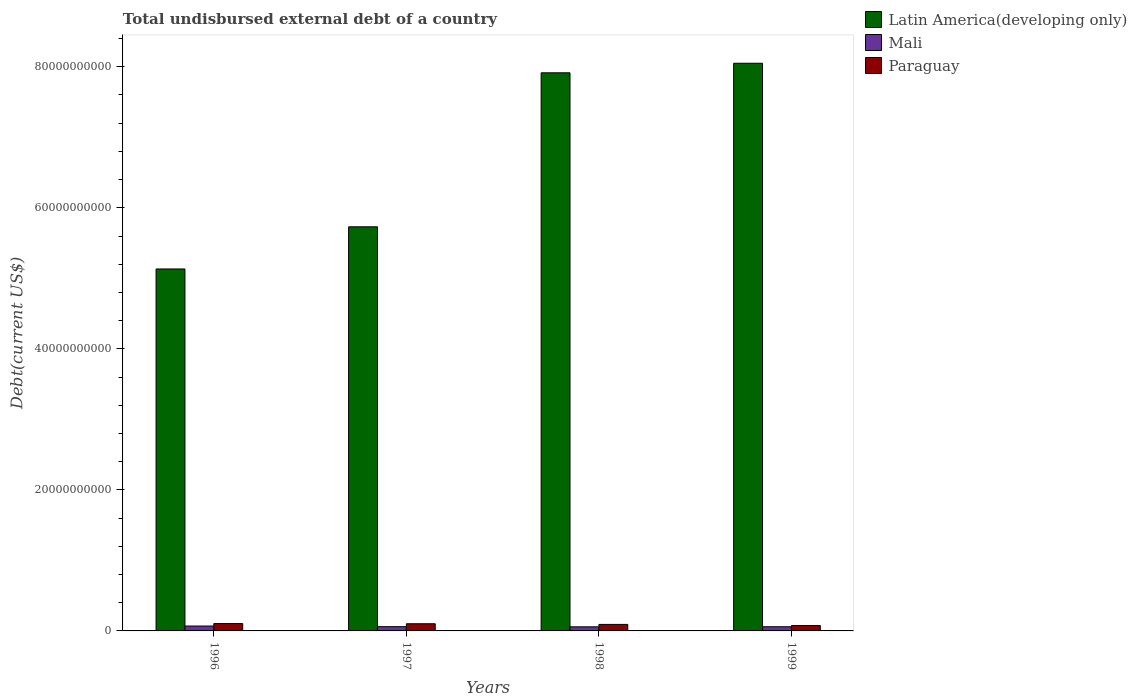How many different coloured bars are there?
Your answer should be compact. 3. How many groups of bars are there?
Keep it short and to the point. 4. Are the number of bars on each tick of the X-axis equal?
Keep it short and to the point. Yes. How many bars are there on the 3rd tick from the left?
Offer a very short reply. 3. What is the label of the 2nd group of bars from the left?
Offer a very short reply. 1997. In how many cases, is the number of bars for a given year not equal to the number of legend labels?
Provide a succinct answer. 0. What is the total undisbursed external debt in Mali in 1996?
Your response must be concise. 6.94e+08. Across all years, what is the maximum total undisbursed external debt in Latin America(developing only)?
Your answer should be very brief. 8.05e+1. Across all years, what is the minimum total undisbursed external debt in Mali?
Provide a short and direct response. 5.82e+08. What is the total total undisbursed external debt in Paraguay in the graph?
Provide a succinct answer. 3.75e+09. What is the difference between the total undisbursed external debt in Mali in 1996 and that in 1998?
Ensure brevity in your answer.  1.12e+08. What is the difference between the total undisbursed external debt in Latin America(developing only) in 1997 and the total undisbursed external debt in Mali in 1999?
Keep it short and to the point. 5.67e+1. What is the average total undisbursed external debt in Latin America(developing only) per year?
Keep it short and to the point. 6.71e+1. In the year 1999, what is the difference between the total undisbursed external debt in Latin America(developing only) and total undisbursed external debt in Paraguay?
Provide a short and direct response. 7.97e+1. What is the ratio of the total undisbursed external debt in Latin America(developing only) in 1997 to that in 1999?
Your answer should be compact. 0.71. Is the total undisbursed external debt in Paraguay in 1996 less than that in 1997?
Make the answer very short. No. What is the difference between the highest and the second highest total undisbursed external debt in Paraguay?
Your answer should be very brief. 2.45e+07. What is the difference between the highest and the lowest total undisbursed external debt in Paraguay?
Give a very brief answer. 2.79e+08. What does the 2nd bar from the left in 1996 represents?
Offer a very short reply. Mali. What does the 3rd bar from the right in 1999 represents?
Your answer should be compact. Latin America(developing only). Is it the case that in every year, the sum of the total undisbursed external debt in Paraguay and total undisbursed external debt in Mali is greater than the total undisbursed external debt in Latin America(developing only)?
Provide a succinct answer. No. How many bars are there?
Make the answer very short. 12. Does the graph contain grids?
Keep it short and to the point. No. Where does the legend appear in the graph?
Offer a terse response. Top right. How many legend labels are there?
Provide a succinct answer. 3. What is the title of the graph?
Make the answer very short. Total undisbursed external debt of a country. Does "Mexico" appear as one of the legend labels in the graph?
Provide a short and direct response. No. What is the label or title of the Y-axis?
Ensure brevity in your answer.  Debt(current US$). What is the Debt(current US$) of Latin America(developing only) in 1996?
Your response must be concise. 5.13e+1. What is the Debt(current US$) in Mali in 1996?
Offer a very short reply. 6.94e+08. What is the Debt(current US$) in Paraguay in 1996?
Provide a succinct answer. 1.04e+09. What is the Debt(current US$) in Latin America(developing only) in 1997?
Offer a very short reply. 5.73e+1. What is the Debt(current US$) in Mali in 1997?
Give a very brief answer. 6.03e+08. What is the Debt(current US$) in Paraguay in 1997?
Offer a very short reply. 1.02e+09. What is the Debt(current US$) in Latin America(developing only) in 1998?
Keep it short and to the point. 7.91e+1. What is the Debt(current US$) of Mali in 1998?
Make the answer very short. 5.82e+08. What is the Debt(current US$) of Paraguay in 1998?
Offer a very short reply. 9.22e+08. What is the Debt(current US$) of Latin America(developing only) in 1999?
Ensure brevity in your answer.  8.05e+1. What is the Debt(current US$) in Mali in 1999?
Keep it short and to the point. 5.93e+08. What is the Debt(current US$) in Paraguay in 1999?
Ensure brevity in your answer.  7.64e+08. Across all years, what is the maximum Debt(current US$) in Latin America(developing only)?
Provide a short and direct response. 8.05e+1. Across all years, what is the maximum Debt(current US$) of Mali?
Give a very brief answer. 6.94e+08. Across all years, what is the maximum Debt(current US$) of Paraguay?
Make the answer very short. 1.04e+09. Across all years, what is the minimum Debt(current US$) of Latin America(developing only)?
Give a very brief answer. 5.13e+1. Across all years, what is the minimum Debt(current US$) of Mali?
Offer a very short reply. 5.82e+08. Across all years, what is the minimum Debt(current US$) of Paraguay?
Offer a very short reply. 7.64e+08. What is the total Debt(current US$) of Latin America(developing only) in the graph?
Provide a short and direct response. 2.68e+11. What is the total Debt(current US$) in Mali in the graph?
Ensure brevity in your answer.  2.47e+09. What is the total Debt(current US$) in Paraguay in the graph?
Make the answer very short. 3.75e+09. What is the difference between the Debt(current US$) in Latin America(developing only) in 1996 and that in 1997?
Your answer should be compact. -5.98e+09. What is the difference between the Debt(current US$) of Mali in 1996 and that in 1997?
Make the answer very short. 9.09e+07. What is the difference between the Debt(current US$) of Paraguay in 1996 and that in 1997?
Offer a very short reply. 2.45e+07. What is the difference between the Debt(current US$) in Latin America(developing only) in 1996 and that in 1998?
Provide a succinct answer. -2.78e+1. What is the difference between the Debt(current US$) of Mali in 1996 and that in 1998?
Make the answer very short. 1.12e+08. What is the difference between the Debt(current US$) in Paraguay in 1996 and that in 1998?
Make the answer very short. 1.21e+08. What is the difference between the Debt(current US$) of Latin America(developing only) in 1996 and that in 1999?
Ensure brevity in your answer.  -2.92e+1. What is the difference between the Debt(current US$) of Mali in 1996 and that in 1999?
Ensure brevity in your answer.  1.01e+08. What is the difference between the Debt(current US$) in Paraguay in 1996 and that in 1999?
Offer a terse response. 2.79e+08. What is the difference between the Debt(current US$) in Latin America(developing only) in 1997 and that in 1998?
Keep it short and to the point. -2.18e+1. What is the difference between the Debt(current US$) of Mali in 1997 and that in 1998?
Give a very brief answer. 2.14e+07. What is the difference between the Debt(current US$) in Paraguay in 1997 and that in 1998?
Give a very brief answer. 9.61e+07. What is the difference between the Debt(current US$) in Latin America(developing only) in 1997 and that in 1999?
Provide a succinct answer. -2.32e+1. What is the difference between the Debt(current US$) in Mali in 1997 and that in 1999?
Offer a terse response. 1.00e+07. What is the difference between the Debt(current US$) in Paraguay in 1997 and that in 1999?
Your response must be concise. 2.54e+08. What is the difference between the Debt(current US$) in Latin America(developing only) in 1998 and that in 1999?
Keep it short and to the point. -1.35e+09. What is the difference between the Debt(current US$) of Mali in 1998 and that in 1999?
Give a very brief answer. -1.13e+07. What is the difference between the Debt(current US$) of Paraguay in 1998 and that in 1999?
Your response must be concise. 1.58e+08. What is the difference between the Debt(current US$) in Latin America(developing only) in 1996 and the Debt(current US$) in Mali in 1997?
Provide a succinct answer. 5.07e+1. What is the difference between the Debt(current US$) in Latin America(developing only) in 1996 and the Debt(current US$) in Paraguay in 1997?
Your answer should be compact. 5.03e+1. What is the difference between the Debt(current US$) in Mali in 1996 and the Debt(current US$) in Paraguay in 1997?
Your answer should be very brief. -3.24e+08. What is the difference between the Debt(current US$) of Latin America(developing only) in 1996 and the Debt(current US$) of Mali in 1998?
Your answer should be very brief. 5.07e+1. What is the difference between the Debt(current US$) in Latin America(developing only) in 1996 and the Debt(current US$) in Paraguay in 1998?
Your answer should be compact. 5.04e+1. What is the difference between the Debt(current US$) in Mali in 1996 and the Debt(current US$) in Paraguay in 1998?
Offer a very short reply. -2.28e+08. What is the difference between the Debt(current US$) of Latin America(developing only) in 1996 and the Debt(current US$) of Mali in 1999?
Your answer should be very brief. 5.07e+1. What is the difference between the Debt(current US$) in Latin America(developing only) in 1996 and the Debt(current US$) in Paraguay in 1999?
Make the answer very short. 5.06e+1. What is the difference between the Debt(current US$) in Mali in 1996 and the Debt(current US$) in Paraguay in 1999?
Provide a short and direct response. -7.03e+07. What is the difference between the Debt(current US$) in Latin America(developing only) in 1997 and the Debt(current US$) in Mali in 1998?
Make the answer very short. 5.67e+1. What is the difference between the Debt(current US$) of Latin America(developing only) in 1997 and the Debt(current US$) of Paraguay in 1998?
Ensure brevity in your answer.  5.64e+1. What is the difference between the Debt(current US$) of Mali in 1997 and the Debt(current US$) of Paraguay in 1998?
Keep it short and to the point. -3.19e+08. What is the difference between the Debt(current US$) in Latin America(developing only) in 1997 and the Debt(current US$) in Mali in 1999?
Your response must be concise. 5.67e+1. What is the difference between the Debt(current US$) in Latin America(developing only) in 1997 and the Debt(current US$) in Paraguay in 1999?
Ensure brevity in your answer.  5.65e+1. What is the difference between the Debt(current US$) in Mali in 1997 and the Debt(current US$) in Paraguay in 1999?
Provide a succinct answer. -1.61e+08. What is the difference between the Debt(current US$) in Latin America(developing only) in 1998 and the Debt(current US$) in Mali in 1999?
Offer a terse response. 7.86e+1. What is the difference between the Debt(current US$) of Latin America(developing only) in 1998 and the Debt(current US$) of Paraguay in 1999?
Your answer should be compact. 7.84e+1. What is the difference between the Debt(current US$) of Mali in 1998 and the Debt(current US$) of Paraguay in 1999?
Make the answer very short. -1.83e+08. What is the average Debt(current US$) of Latin America(developing only) per year?
Make the answer very short. 6.71e+1. What is the average Debt(current US$) of Mali per year?
Ensure brevity in your answer.  6.18e+08. What is the average Debt(current US$) of Paraguay per year?
Offer a very short reply. 9.37e+08. In the year 1996, what is the difference between the Debt(current US$) of Latin America(developing only) and Debt(current US$) of Mali?
Your answer should be very brief. 5.06e+1. In the year 1996, what is the difference between the Debt(current US$) of Latin America(developing only) and Debt(current US$) of Paraguay?
Your response must be concise. 5.03e+1. In the year 1996, what is the difference between the Debt(current US$) in Mali and Debt(current US$) in Paraguay?
Make the answer very short. -3.49e+08. In the year 1997, what is the difference between the Debt(current US$) of Latin America(developing only) and Debt(current US$) of Mali?
Ensure brevity in your answer.  5.67e+1. In the year 1997, what is the difference between the Debt(current US$) of Latin America(developing only) and Debt(current US$) of Paraguay?
Give a very brief answer. 5.63e+1. In the year 1997, what is the difference between the Debt(current US$) in Mali and Debt(current US$) in Paraguay?
Offer a very short reply. -4.15e+08. In the year 1998, what is the difference between the Debt(current US$) in Latin America(developing only) and Debt(current US$) in Mali?
Offer a very short reply. 7.86e+1. In the year 1998, what is the difference between the Debt(current US$) in Latin America(developing only) and Debt(current US$) in Paraguay?
Your answer should be compact. 7.82e+1. In the year 1998, what is the difference between the Debt(current US$) in Mali and Debt(current US$) in Paraguay?
Keep it short and to the point. -3.40e+08. In the year 1999, what is the difference between the Debt(current US$) in Latin America(developing only) and Debt(current US$) in Mali?
Provide a succinct answer. 7.99e+1. In the year 1999, what is the difference between the Debt(current US$) of Latin America(developing only) and Debt(current US$) of Paraguay?
Your answer should be very brief. 7.97e+1. In the year 1999, what is the difference between the Debt(current US$) of Mali and Debt(current US$) of Paraguay?
Offer a terse response. -1.71e+08. What is the ratio of the Debt(current US$) in Latin America(developing only) in 1996 to that in 1997?
Provide a succinct answer. 0.9. What is the ratio of the Debt(current US$) in Mali in 1996 to that in 1997?
Keep it short and to the point. 1.15. What is the ratio of the Debt(current US$) of Paraguay in 1996 to that in 1997?
Provide a succinct answer. 1.02. What is the ratio of the Debt(current US$) of Latin America(developing only) in 1996 to that in 1998?
Make the answer very short. 0.65. What is the ratio of the Debt(current US$) of Mali in 1996 to that in 1998?
Provide a succinct answer. 1.19. What is the ratio of the Debt(current US$) in Paraguay in 1996 to that in 1998?
Offer a very short reply. 1.13. What is the ratio of the Debt(current US$) in Latin America(developing only) in 1996 to that in 1999?
Make the answer very short. 0.64. What is the ratio of the Debt(current US$) of Mali in 1996 to that in 1999?
Offer a very short reply. 1.17. What is the ratio of the Debt(current US$) in Paraguay in 1996 to that in 1999?
Your answer should be compact. 1.36. What is the ratio of the Debt(current US$) of Latin America(developing only) in 1997 to that in 1998?
Keep it short and to the point. 0.72. What is the ratio of the Debt(current US$) of Mali in 1997 to that in 1998?
Make the answer very short. 1.04. What is the ratio of the Debt(current US$) of Paraguay in 1997 to that in 1998?
Keep it short and to the point. 1.1. What is the ratio of the Debt(current US$) in Latin America(developing only) in 1997 to that in 1999?
Ensure brevity in your answer.  0.71. What is the ratio of the Debt(current US$) in Mali in 1997 to that in 1999?
Your response must be concise. 1.02. What is the ratio of the Debt(current US$) of Paraguay in 1997 to that in 1999?
Keep it short and to the point. 1.33. What is the ratio of the Debt(current US$) in Latin America(developing only) in 1998 to that in 1999?
Provide a succinct answer. 0.98. What is the ratio of the Debt(current US$) in Mali in 1998 to that in 1999?
Your answer should be very brief. 0.98. What is the ratio of the Debt(current US$) of Paraguay in 1998 to that in 1999?
Provide a succinct answer. 1.21. What is the difference between the highest and the second highest Debt(current US$) of Latin America(developing only)?
Keep it short and to the point. 1.35e+09. What is the difference between the highest and the second highest Debt(current US$) of Mali?
Your answer should be very brief. 9.09e+07. What is the difference between the highest and the second highest Debt(current US$) of Paraguay?
Offer a very short reply. 2.45e+07. What is the difference between the highest and the lowest Debt(current US$) in Latin America(developing only)?
Offer a very short reply. 2.92e+1. What is the difference between the highest and the lowest Debt(current US$) of Mali?
Give a very brief answer. 1.12e+08. What is the difference between the highest and the lowest Debt(current US$) of Paraguay?
Keep it short and to the point. 2.79e+08. 